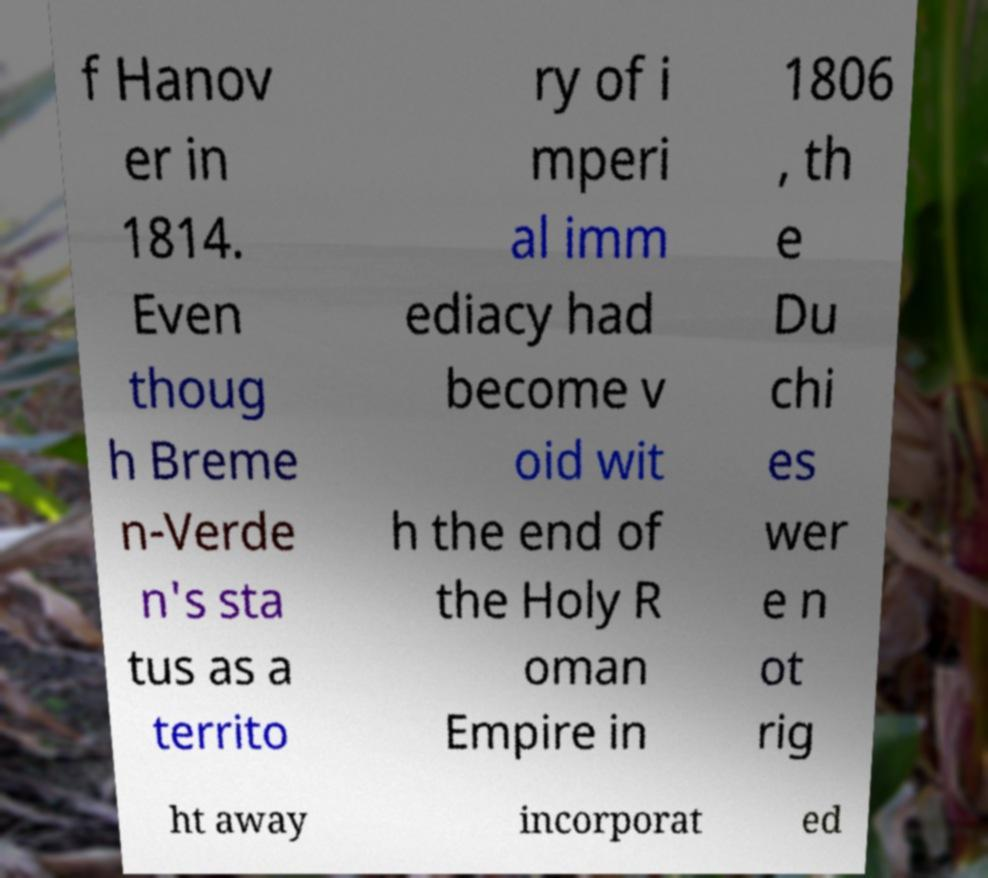Please read and relay the text visible in this image. What does it say? f Hanov er in 1814. Even thoug h Breme n-Verde n's sta tus as a territo ry of i mperi al imm ediacy had become v oid wit h the end of the Holy R oman Empire in 1806 , th e Du chi es wer e n ot rig ht away incorporat ed 